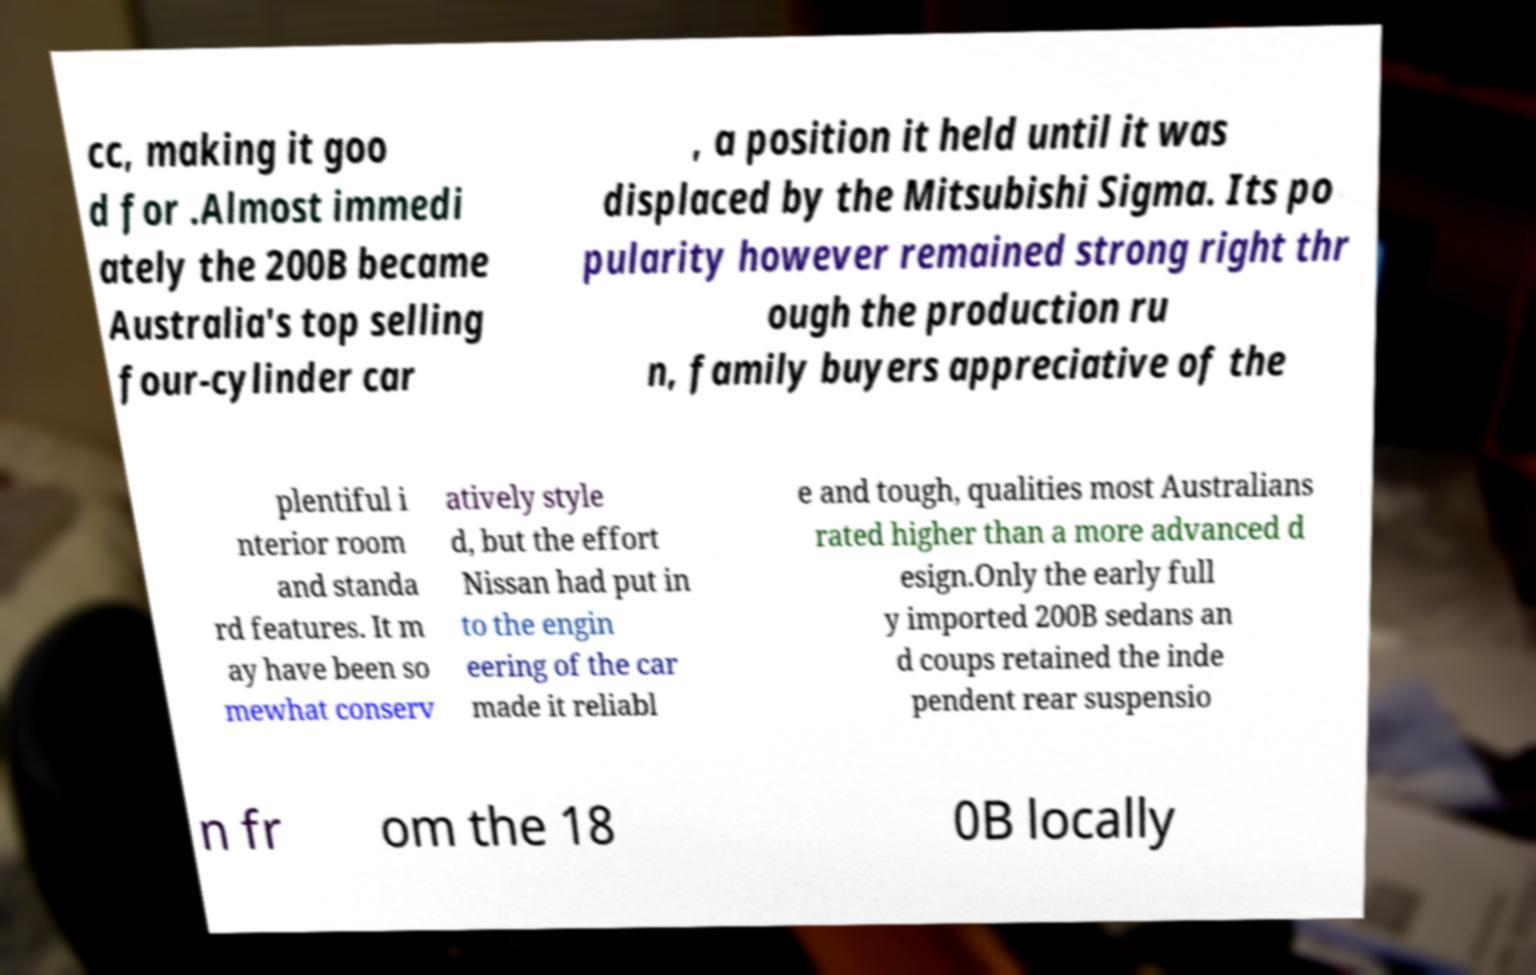I need the written content from this picture converted into text. Can you do that? cc, making it goo d for .Almost immedi ately the 200B became Australia's top selling four-cylinder car , a position it held until it was displaced by the Mitsubishi Sigma. Its po pularity however remained strong right thr ough the production ru n, family buyers appreciative of the plentiful i nterior room and standa rd features. It m ay have been so mewhat conserv atively style d, but the effort Nissan had put in to the engin eering of the car made it reliabl e and tough, qualities most Australians rated higher than a more advanced d esign.Only the early full y imported 200B sedans an d coups retained the inde pendent rear suspensio n fr om the 18 0B locally 